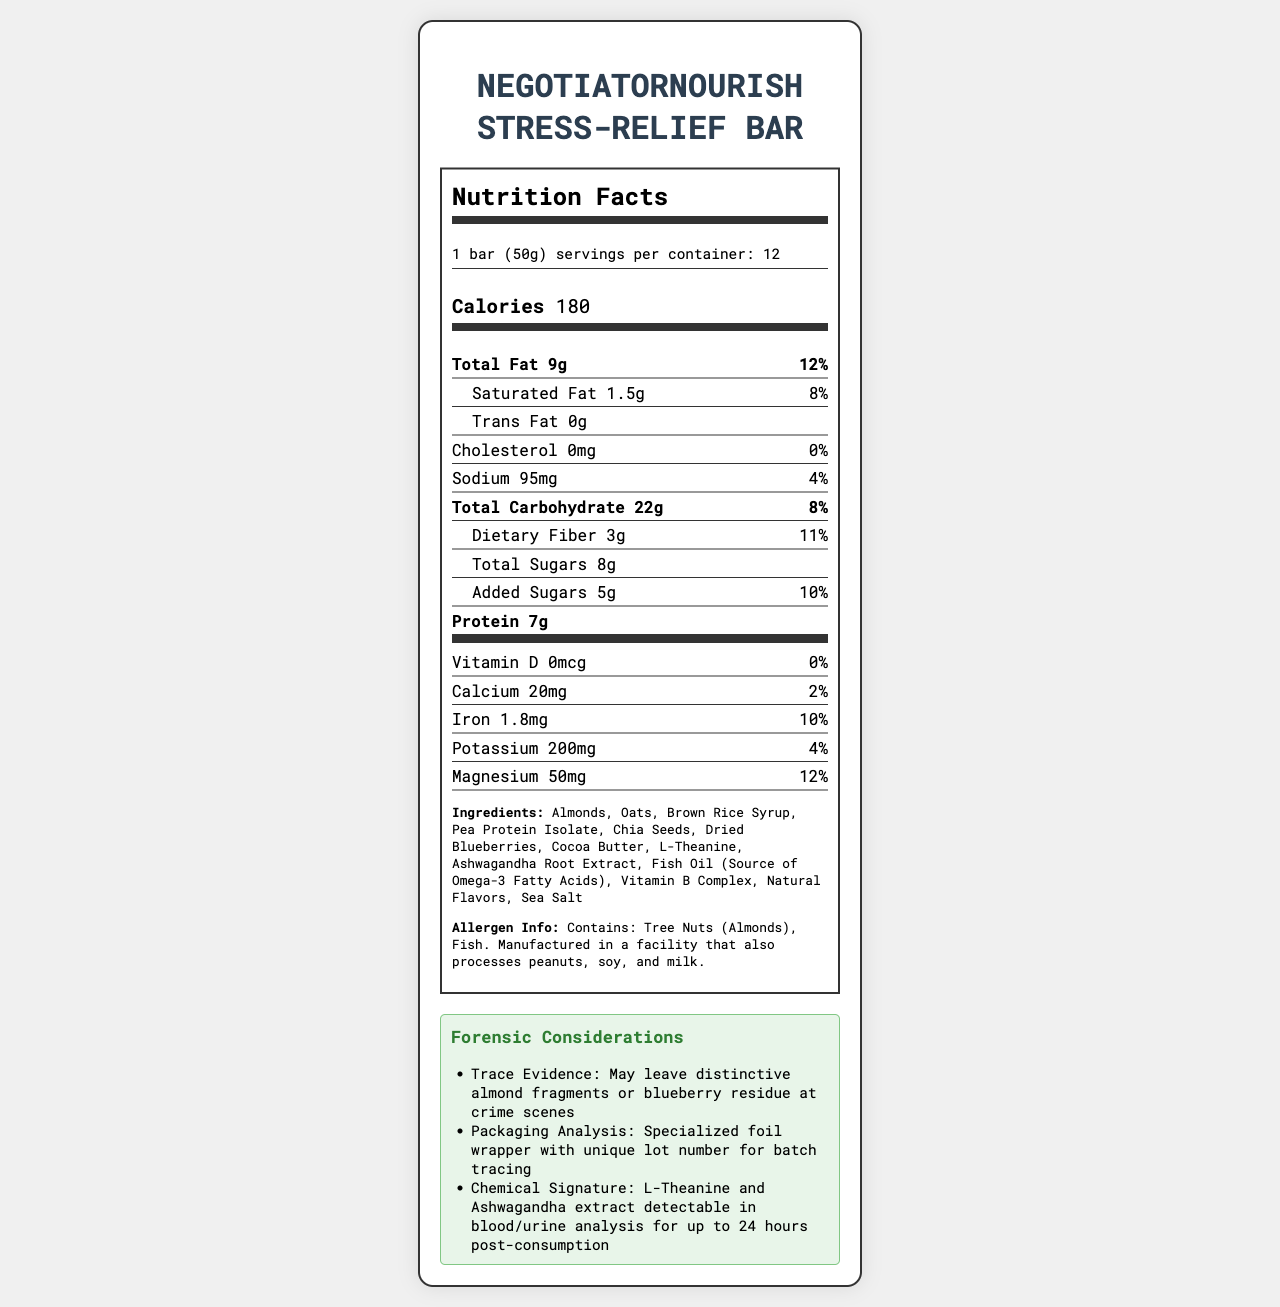what is the serving size of the NegotiatorNourish Stress-Relief Bar? The serving size is explicitly stated as "1 bar (50g)".
Answer: 1 bar (50g) how many calories are in a single bar? The document lists the calorie content as 180 per serving.
Answer: 180 which ingredients mentioned could leave distinctive traces at a crime scene? The forensic considerations section mentions that almond fragments or blueberry residue may be left at crime scenes.
Answer: Almonds, Dried Blueberries how many grams of protein are in each serving? The document lists protein content as 7g per serving.
Answer: 7g what are the benefits of this snack for crisis negotiators? The benefits mentioned include promoting calmness, supporting cognitive function, decision-making under pressure, maintaining focus, and providing sustained energy without caffeine crashes.
Answer: Promotes calmness and reduces anxiety, supports cognitive function and decision-making, helps maintain focus, provides sustained energy what is the daily value percentage of magnesium in one bar? The magnesium content is 50mg, which is 12% of the daily value.
Answer: 12% how many servings are in one container? The serving info section states there are 12 servings per container.
Answer: 12 which of the following ingredients is a source of omega-3 fatty acids?
A. Chia Seeds
B. Fish Oil
C. Almonds
D. Cocoa Butter Fish Oil is explicitly mentioned as the source of Omega-3 Fatty Acids.
Answer: B how is the product packaged for forensic purposes?
A. Distinctive plastic wrap
B. Specialized foil wrapper with unique lot number
C. Recyclable paper packaging
D. Vacuum-sealed bag The packaging analysis section mentions a specialized foil wrapper with a unique lot number for batch tracing.
Answer: B does this product contain any caffeine? The document does not mention caffeine as an ingredient or component.
Answer: No summarize the main features presented in the document. The summary covers nutrition facts, ingredients, forensic details, and benefits for crisis negotiators.
Answer: The document details the nutritional information of the NegotiatorNourish Stress-Relief Bar, a snack formulated for crisis negotiators. It includes serving size, calorie content, and amounts of various nutrients such as fats, carbohydrates, proteins, vitamins, and minerals. The ingredients and allergen information are also provided. Additionally, forensic considerations like trace evidence, packaging, and chemical signatures are described. The benefits for crisis negotiators and manufacturer information are also included. what is the main source of dietary fiber in the NegotiatorNourish Bar? The document does not specify which ingredient is the main source of dietary fiber.
Answer: Cannot be determined 